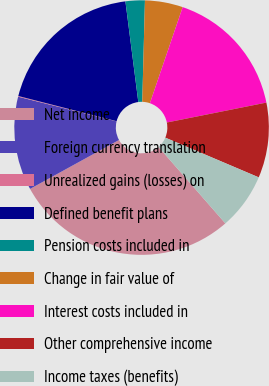Convert chart to OTSL. <chart><loc_0><loc_0><loc_500><loc_500><pie_chart><fcel>Net income<fcel>Foreign currency translation<fcel>Unrealized gains (losses) on<fcel>Defined benefit plans<fcel>Pension costs included in<fcel>Change in fair value of<fcel>Interest costs included in<fcel>Other comprehensive income<fcel>Income taxes (benefits)<nl><fcel>28.43%<fcel>11.9%<fcel>0.09%<fcel>18.98%<fcel>2.45%<fcel>4.81%<fcel>16.62%<fcel>9.54%<fcel>7.17%<nl></chart> 